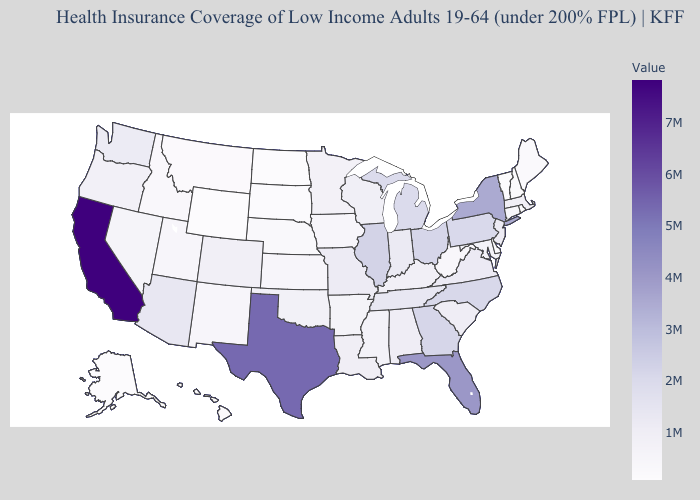Does Texas have the highest value in the South?
Keep it brief. Yes. Which states have the highest value in the USA?
Short answer required. California. Does Pennsylvania have a higher value than New Mexico?
Give a very brief answer. Yes. Among the states that border New Jersey , does New York have the highest value?
Write a very short answer. Yes. Is the legend a continuous bar?
Quick response, please. Yes. 